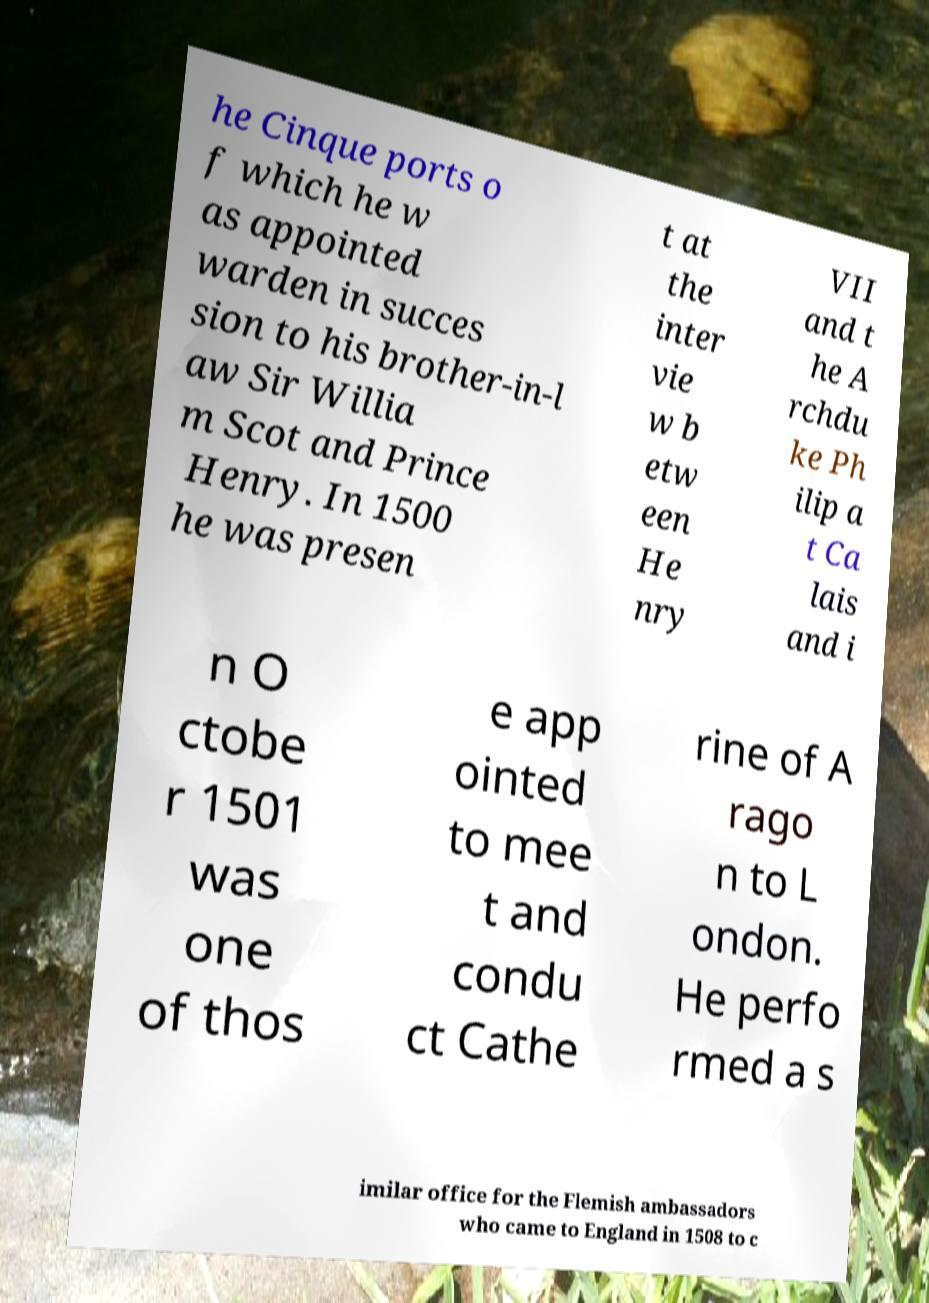There's text embedded in this image that I need extracted. Can you transcribe it verbatim? he Cinque ports o f which he w as appointed warden in succes sion to his brother-in-l aw Sir Willia m Scot and Prince Henry. In 1500 he was presen t at the inter vie w b etw een He nry VII and t he A rchdu ke Ph ilip a t Ca lais and i n O ctobe r 1501 was one of thos e app ointed to mee t and condu ct Cathe rine of A rago n to L ondon. He perfo rmed a s imilar office for the Flemish ambassadors who came to England in 1508 to c 